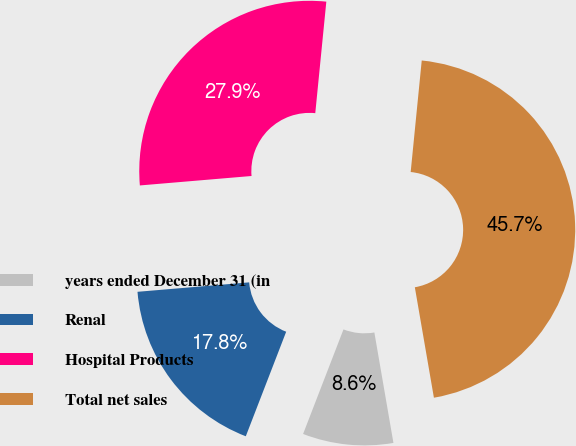<chart> <loc_0><loc_0><loc_500><loc_500><pie_chart><fcel>years ended December 31 (in<fcel>Renal<fcel>Hospital Products<fcel>Total net sales<nl><fcel>8.59%<fcel>17.79%<fcel>27.92%<fcel>45.71%<nl></chart> 